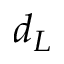<formula> <loc_0><loc_0><loc_500><loc_500>d _ { L }</formula> 